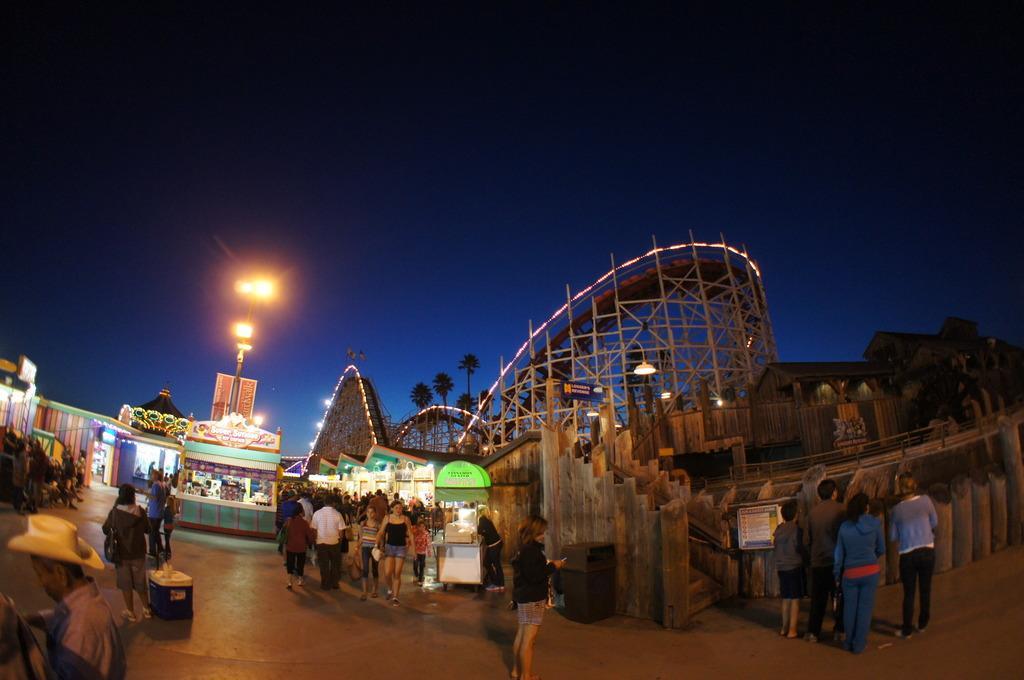How would you summarize this image in a sentence or two? There are people, we can see box and bin on the surface. We can see stalls, houses, rods, lights, fence, board and pole. In the background we can see trees and sky in blue color. 